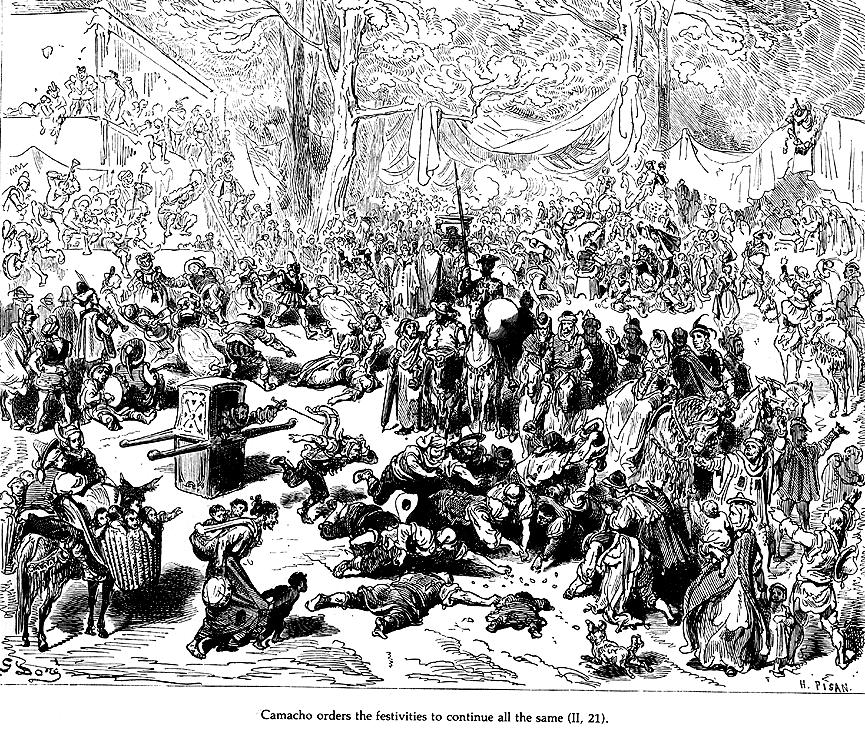Why does the artist use such crowded and detailed composition? The artist uses a crowded and detailed composition to reflect the chaos and vibrancy of the festive scene depicted in 'Don Quixote'. Each character is rendered with distinct expressions and poses, suggesting a spectrum of emotions and social interactions. This approach not only captures the festive spirit but also allows for a visual exploration of 17th-century societal norms, festivals, and attire, providing a deeper understanding of the historical and cultural context of the setting. 